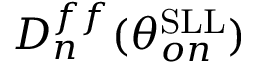Convert formula to latex. <formula><loc_0><loc_0><loc_500><loc_500>D _ { n } ^ { f f } ( \theta _ { o n } ^ { S L L } )</formula> 